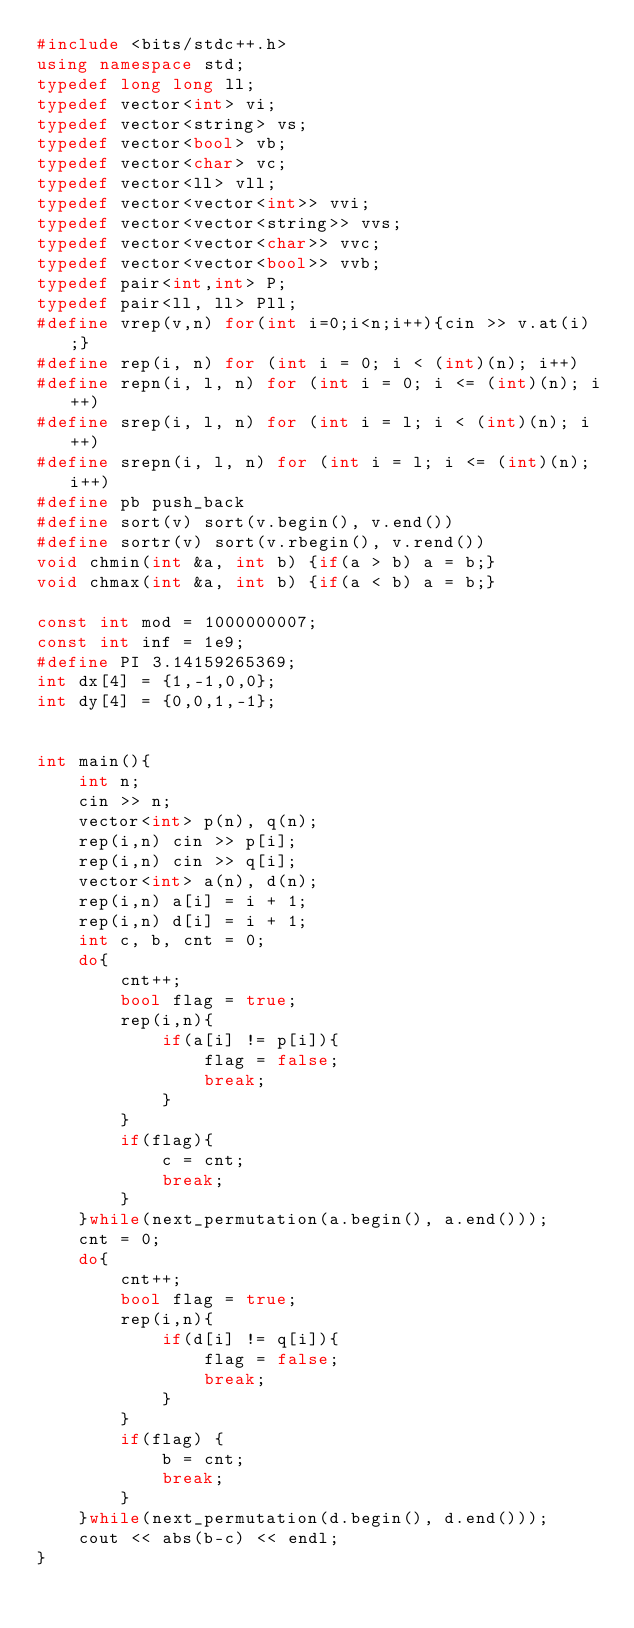<code> <loc_0><loc_0><loc_500><loc_500><_C++_>#include <bits/stdc++.h>
using namespace std;
typedef long long ll;
typedef vector<int> vi;
typedef vector<string> vs;
typedef vector<bool> vb;
typedef vector<char> vc;
typedef vector<ll> vll;
typedef vector<vector<int>> vvi;
typedef vector<vector<string>> vvs;
typedef vector<vector<char>> vvc;
typedef vector<vector<bool>> vvb;
typedef pair<int,int> P;
typedef pair<ll, ll> Pll;
#define vrep(v,n) for(int i=0;i<n;i++){cin >> v.at(i);} 
#define rep(i, n) for (int i = 0; i < (int)(n); i++)
#define repn(i, l, n) for (int i = 0; i <= (int)(n); i++)
#define srep(i, l, n) for (int i = l; i < (int)(n); i++)
#define srepn(i, l, n) for (int i = l; i <= (int)(n); i++)
#define pb push_back 
#define sort(v) sort(v.begin(), v.end())
#define sortr(v) sort(v.rbegin(), v.rend())
void chmin(int &a, int b) {if(a > b) a = b;}
void chmax(int &a, int b) {if(a < b) a = b;}

const int mod = 1000000007;
const int inf = 1e9;
#define PI 3.14159265369;
int dx[4] = {1,-1,0,0};
int dy[4] = {0,0,1,-1};


int main(){
    int n;
    cin >> n;
    vector<int> p(n), q(n);
    rep(i,n) cin >> p[i];
    rep(i,n) cin >> q[i];
    vector<int> a(n), d(n);
    rep(i,n) a[i] = i + 1;
    rep(i,n) d[i] = i + 1;
    int c, b, cnt = 0;
    do{
        cnt++;
        bool flag = true;
        rep(i,n){
            if(a[i] != p[i]){
                flag = false;
                break;
            }
        }
        if(flag){
            c = cnt;
            break;
        }
    }while(next_permutation(a.begin(), a.end()));
    cnt = 0;
    do{
        cnt++;
        bool flag = true;
        rep(i,n){
            if(d[i] != q[i]){
                flag = false;
                break;
            }
        }
        if(flag) {
            b = cnt;
            break;
        }
    }while(next_permutation(d.begin(), d.end()));
    cout << abs(b-c) << endl;
}</code> 